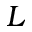Convert formula to latex. <formula><loc_0><loc_0><loc_500><loc_500>L</formula> 